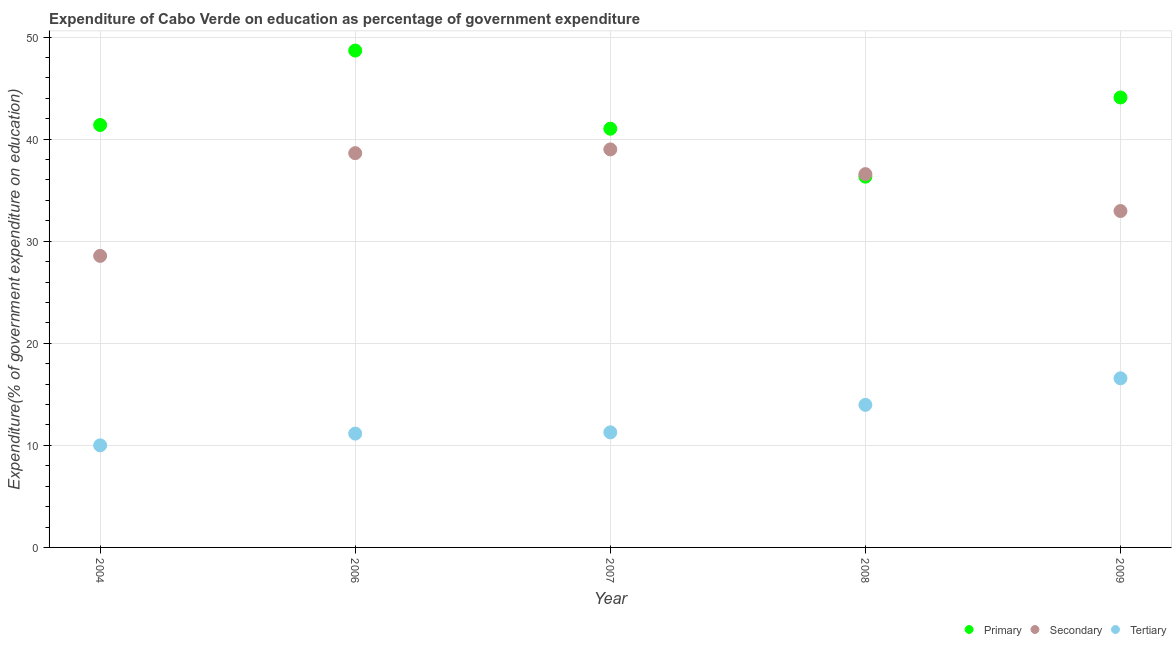How many different coloured dotlines are there?
Offer a very short reply. 3. What is the expenditure on primary education in 2007?
Offer a terse response. 41.02. Across all years, what is the maximum expenditure on secondary education?
Ensure brevity in your answer.  38.99. Across all years, what is the minimum expenditure on primary education?
Ensure brevity in your answer.  36.32. In which year was the expenditure on tertiary education maximum?
Offer a very short reply. 2009. What is the total expenditure on tertiary education in the graph?
Ensure brevity in your answer.  62.96. What is the difference between the expenditure on tertiary education in 2006 and that in 2009?
Provide a succinct answer. -5.42. What is the difference between the expenditure on primary education in 2007 and the expenditure on secondary education in 2004?
Make the answer very short. 12.46. What is the average expenditure on secondary education per year?
Provide a short and direct response. 35.14. In the year 2008, what is the difference between the expenditure on primary education and expenditure on secondary education?
Offer a very short reply. -0.25. What is the ratio of the expenditure on secondary education in 2006 to that in 2008?
Provide a succinct answer. 1.06. Is the expenditure on secondary education in 2008 less than that in 2009?
Offer a very short reply. No. Is the difference between the expenditure on secondary education in 2006 and 2009 greater than the difference between the expenditure on tertiary education in 2006 and 2009?
Provide a succinct answer. Yes. What is the difference between the highest and the second highest expenditure on primary education?
Give a very brief answer. 4.6. What is the difference between the highest and the lowest expenditure on secondary education?
Provide a succinct answer. 10.43. In how many years, is the expenditure on secondary education greater than the average expenditure on secondary education taken over all years?
Your answer should be compact. 3. Does the expenditure on primary education monotonically increase over the years?
Offer a very short reply. No. Is the expenditure on primary education strictly greater than the expenditure on tertiary education over the years?
Make the answer very short. Yes. Is the expenditure on tertiary education strictly less than the expenditure on secondary education over the years?
Offer a terse response. Yes. How many dotlines are there?
Keep it short and to the point. 3. What is the difference between two consecutive major ticks on the Y-axis?
Your response must be concise. 10. Are the values on the major ticks of Y-axis written in scientific E-notation?
Ensure brevity in your answer.  No. Does the graph contain grids?
Your answer should be compact. Yes. Where does the legend appear in the graph?
Make the answer very short. Bottom right. What is the title of the graph?
Give a very brief answer. Expenditure of Cabo Verde on education as percentage of government expenditure. What is the label or title of the Y-axis?
Provide a succinct answer. Expenditure(% of government expenditure on education). What is the Expenditure(% of government expenditure on education) of Primary in 2004?
Offer a very short reply. 41.38. What is the Expenditure(% of government expenditure on education) in Secondary in 2004?
Your response must be concise. 28.56. What is the Expenditure(% of government expenditure on education) in Tertiary in 2004?
Provide a succinct answer. 10. What is the Expenditure(% of government expenditure on education) in Primary in 2006?
Your answer should be compact. 48.68. What is the Expenditure(% of government expenditure on education) of Secondary in 2006?
Ensure brevity in your answer.  38.63. What is the Expenditure(% of government expenditure on education) in Tertiary in 2006?
Provide a short and direct response. 11.15. What is the Expenditure(% of government expenditure on education) of Primary in 2007?
Offer a terse response. 41.02. What is the Expenditure(% of government expenditure on education) of Secondary in 2007?
Ensure brevity in your answer.  38.99. What is the Expenditure(% of government expenditure on education) of Tertiary in 2007?
Your answer should be compact. 11.27. What is the Expenditure(% of government expenditure on education) in Primary in 2008?
Your response must be concise. 36.32. What is the Expenditure(% of government expenditure on education) of Secondary in 2008?
Your answer should be compact. 36.57. What is the Expenditure(% of government expenditure on education) in Tertiary in 2008?
Provide a succinct answer. 13.97. What is the Expenditure(% of government expenditure on education) in Primary in 2009?
Offer a very short reply. 44.08. What is the Expenditure(% of government expenditure on education) of Secondary in 2009?
Provide a short and direct response. 32.96. What is the Expenditure(% of government expenditure on education) of Tertiary in 2009?
Offer a very short reply. 16.57. Across all years, what is the maximum Expenditure(% of government expenditure on education) in Primary?
Offer a very short reply. 48.68. Across all years, what is the maximum Expenditure(% of government expenditure on education) in Secondary?
Offer a terse response. 38.99. Across all years, what is the maximum Expenditure(% of government expenditure on education) of Tertiary?
Keep it short and to the point. 16.57. Across all years, what is the minimum Expenditure(% of government expenditure on education) in Primary?
Offer a very short reply. 36.32. Across all years, what is the minimum Expenditure(% of government expenditure on education) in Secondary?
Provide a succinct answer. 28.56. Across all years, what is the minimum Expenditure(% of government expenditure on education) in Tertiary?
Offer a terse response. 10. What is the total Expenditure(% of government expenditure on education) of Primary in the graph?
Your answer should be very brief. 211.49. What is the total Expenditure(% of government expenditure on education) of Secondary in the graph?
Offer a terse response. 175.71. What is the total Expenditure(% of government expenditure on education) in Tertiary in the graph?
Make the answer very short. 62.96. What is the difference between the Expenditure(% of government expenditure on education) of Primary in 2004 and that in 2006?
Make the answer very short. -7.29. What is the difference between the Expenditure(% of government expenditure on education) in Secondary in 2004 and that in 2006?
Offer a very short reply. -10.06. What is the difference between the Expenditure(% of government expenditure on education) of Tertiary in 2004 and that in 2006?
Your response must be concise. -1.15. What is the difference between the Expenditure(% of government expenditure on education) in Primary in 2004 and that in 2007?
Your answer should be compact. 0.36. What is the difference between the Expenditure(% of government expenditure on education) of Secondary in 2004 and that in 2007?
Keep it short and to the point. -10.43. What is the difference between the Expenditure(% of government expenditure on education) of Tertiary in 2004 and that in 2007?
Give a very brief answer. -1.28. What is the difference between the Expenditure(% of government expenditure on education) of Primary in 2004 and that in 2008?
Keep it short and to the point. 5.06. What is the difference between the Expenditure(% of government expenditure on education) of Secondary in 2004 and that in 2008?
Your response must be concise. -8.01. What is the difference between the Expenditure(% of government expenditure on education) in Tertiary in 2004 and that in 2008?
Keep it short and to the point. -3.97. What is the difference between the Expenditure(% of government expenditure on education) of Primary in 2004 and that in 2009?
Offer a terse response. -2.7. What is the difference between the Expenditure(% of government expenditure on education) in Secondary in 2004 and that in 2009?
Provide a succinct answer. -4.4. What is the difference between the Expenditure(% of government expenditure on education) in Tertiary in 2004 and that in 2009?
Your response must be concise. -6.57. What is the difference between the Expenditure(% of government expenditure on education) of Primary in 2006 and that in 2007?
Your answer should be very brief. 7.66. What is the difference between the Expenditure(% of government expenditure on education) in Secondary in 2006 and that in 2007?
Your answer should be very brief. -0.37. What is the difference between the Expenditure(% of government expenditure on education) of Tertiary in 2006 and that in 2007?
Offer a terse response. -0.12. What is the difference between the Expenditure(% of government expenditure on education) in Primary in 2006 and that in 2008?
Provide a short and direct response. 12.35. What is the difference between the Expenditure(% of government expenditure on education) of Secondary in 2006 and that in 2008?
Offer a terse response. 2.05. What is the difference between the Expenditure(% of government expenditure on education) in Tertiary in 2006 and that in 2008?
Offer a terse response. -2.81. What is the difference between the Expenditure(% of government expenditure on education) in Primary in 2006 and that in 2009?
Your answer should be compact. 4.6. What is the difference between the Expenditure(% of government expenditure on education) of Secondary in 2006 and that in 2009?
Provide a short and direct response. 5.67. What is the difference between the Expenditure(% of government expenditure on education) in Tertiary in 2006 and that in 2009?
Your answer should be very brief. -5.42. What is the difference between the Expenditure(% of government expenditure on education) in Primary in 2007 and that in 2008?
Ensure brevity in your answer.  4.7. What is the difference between the Expenditure(% of government expenditure on education) of Secondary in 2007 and that in 2008?
Offer a terse response. 2.42. What is the difference between the Expenditure(% of government expenditure on education) in Tertiary in 2007 and that in 2008?
Your answer should be very brief. -2.69. What is the difference between the Expenditure(% of government expenditure on education) in Primary in 2007 and that in 2009?
Provide a succinct answer. -3.06. What is the difference between the Expenditure(% of government expenditure on education) in Secondary in 2007 and that in 2009?
Provide a succinct answer. 6.04. What is the difference between the Expenditure(% of government expenditure on education) of Tertiary in 2007 and that in 2009?
Provide a succinct answer. -5.3. What is the difference between the Expenditure(% of government expenditure on education) in Primary in 2008 and that in 2009?
Your answer should be very brief. -7.76. What is the difference between the Expenditure(% of government expenditure on education) of Secondary in 2008 and that in 2009?
Your answer should be compact. 3.62. What is the difference between the Expenditure(% of government expenditure on education) of Tertiary in 2008 and that in 2009?
Ensure brevity in your answer.  -2.6. What is the difference between the Expenditure(% of government expenditure on education) in Primary in 2004 and the Expenditure(% of government expenditure on education) in Secondary in 2006?
Provide a succinct answer. 2.76. What is the difference between the Expenditure(% of government expenditure on education) in Primary in 2004 and the Expenditure(% of government expenditure on education) in Tertiary in 2006?
Ensure brevity in your answer.  30.23. What is the difference between the Expenditure(% of government expenditure on education) in Secondary in 2004 and the Expenditure(% of government expenditure on education) in Tertiary in 2006?
Your response must be concise. 17.41. What is the difference between the Expenditure(% of government expenditure on education) of Primary in 2004 and the Expenditure(% of government expenditure on education) of Secondary in 2007?
Your response must be concise. 2.39. What is the difference between the Expenditure(% of government expenditure on education) of Primary in 2004 and the Expenditure(% of government expenditure on education) of Tertiary in 2007?
Your answer should be very brief. 30.11. What is the difference between the Expenditure(% of government expenditure on education) of Secondary in 2004 and the Expenditure(% of government expenditure on education) of Tertiary in 2007?
Ensure brevity in your answer.  17.29. What is the difference between the Expenditure(% of government expenditure on education) of Primary in 2004 and the Expenditure(% of government expenditure on education) of Secondary in 2008?
Make the answer very short. 4.81. What is the difference between the Expenditure(% of government expenditure on education) of Primary in 2004 and the Expenditure(% of government expenditure on education) of Tertiary in 2008?
Your answer should be very brief. 27.42. What is the difference between the Expenditure(% of government expenditure on education) of Secondary in 2004 and the Expenditure(% of government expenditure on education) of Tertiary in 2008?
Your response must be concise. 14.6. What is the difference between the Expenditure(% of government expenditure on education) of Primary in 2004 and the Expenditure(% of government expenditure on education) of Secondary in 2009?
Offer a very short reply. 8.43. What is the difference between the Expenditure(% of government expenditure on education) in Primary in 2004 and the Expenditure(% of government expenditure on education) in Tertiary in 2009?
Your answer should be compact. 24.81. What is the difference between the Expenditure(% of government expenditure on education) of Secondary in 2004 and the Expenditure(% of government expenditure on education) of Tertiary in 2009?
Make the answer very short. 11.99. What is the difference between the Expenditure(% of government expenditure on education) of Primary in 2006 and the Expenditure(% of government expenditure on education) of Secondary in 2007?
Provide a short and direct response. 9.68. What is the difference between the Expenditure(% of government expenditure on education) of Primary in 2006 and the Expenditure(% of government expenditure on education) of Tertiary in 2007?
Your response must be concise. 37.4. What is the difference between the Expenditure(% of government expenditure on education) of Secondary in 2006 and the Expenditure(% of government expenditure on education) of Tertiary in 2007?
Offer a terse response. 27.35. What is the difference between the Expenditure(% of government expenditure on education) in Primary in 2006 and the Expenditure(% of government expenditure on education) in Secondary in 2008?
Your answer should be very brief. 12.1. What is the difference between the Expenditure(% of government expenditure on education) of Primary in 2006 and the Expenditure(% of government expenditure on education) of Tertiary in 2008?
Offer a terse response. 34.71. What is the difference between the Expenditure(% of government expenditure on education) in Secondary in 2006 and the Expenditure(% of government expenditure on education) in Tertiary in 2008?
Make the answer very short. 24.66. What is the difference between the Expenditure(% of government expenditure on education) in Primary in 2006 and the Expenditure(% of government expenditure on education) in Secondary in 2009?
Make the answer very short. 15.72. What is the difference between the Expenditure(% of government expenditure on education) of Primary in 2006 and the Expenditure(% of government expenditure on education) of Tertiary in 2009?
Your answer should be compact. 32.11. What is the difference between the Expenditure(% of government expenditure on education) in Secondary in 2006 and the Expenditure(% of government expenditure on education) in Tertiary in 2009?
Your answer should be compact. 22.06. What is the difference between the Expenditure(% of government expenditure on education) of Primary in 2007 and the Expenditure(% of government expenditure on education) of Secondary in 2008?
Ensure brevity in your answer.  4.45. What is the difference between the Expenditure(% of government expenditure on education) of Primary in 2007 and the Expenditure(% of government expenditure on education) of Tertiary in 2008?
Offer a very short reply. 27.05. What is the difference between the Expenditure(% of government expenditure on education) in Secondary in 2007 and the Expenditure(% of government expenditure on education) in Tertiary in 2008?
Offer a very short reply. 25.03. What is the difference between the Expenditure(% of government expenditure on education) in Primary in 2007 and the Expenditure(% of government expenditure on education) in Secondary in 2009?
Your answer should be compact. 8.06. What is the difference between the Expenditure(% of government expenditure on education) in Primary in 2007 and the Expenditure(% of government expenditure on education) in Tertiary in 2009?
Provide a short and direct response. 24.45. What is the difference between the Expenditure(% of government expenditure on education) of Secondary in 2007 and the Expenditure(% of government expenditure on education) of Tertiary in 2009?
Offer a very short reply. 22.42. What is the difference between the Expenditure(% of government expenditure on education) in Primary in 2008 and the Expenditure(% of government expenditure on education) in Secondary in 2009?
Ensure brevity in your answer.  3.37. What is the difference between the Expenditure(% of government expenditure on education) in Primary in 2008 and the Expenditure(% of government expenditure on education) in Tertiary in 2009?
Your answer should be very brief. 19.75. What is the difference between the Expenditure(% of government expenditure on education) of Secondary in 2008 and the Expenditure(% of government expenditure on education) of Tertiary in 2009?
Your response must be concise. 20. What is the average Expenditure(% of government expenditure on education) of Primary per year?
Offer a very short reply. 42.3. What is the average Expenditure(% of government expenditure on education) in Secondary per year?
Offer a very short reply. 35.14. What is the average Expenditure(% of government expenditure on education) in Tertiary per year?
Offer a terse response. 12.59. In the year 2004, what is the difference between the Expenditure(% of government expenditure on education) of Primary and Expenditure(% of government expenditure on education) of Secondary?
Ensure brevity in your answer.  12.82. In the year 2004, what is the difference between the Expenditure(% of government expenditure on education) in Primary and Expenditure(% of government expenditure on education) in Tertiary?
Provide a short and direct response. 31.39. In the year 2004, what is the difference between the Expenditure(% of government expenditure on education) of Secondary and Expenditure(% of government expenditure on education) of Tertiary?
Make the answer very short. 18.56. In the year 2006, what is the difference between the Expenditure(% of government expenditure on education) in Primary and Expenditure(% of government expenditure on education) in Secondary?
Provide a succinct answer. 10.05. In the year 2006, what is the difference between the Expenditure(% of government expenditure on education) of Primary and Expenditure(% of government expenditure on education) of Tertiary?
Ensure brevity in your answer.  37.53. In the year 2006, what is the difference between the Expenditure(% of government expenditure on education) in Secondary and Expenditure(% of government expenditure on education) in Tertiary?
Make the answer very short. 27.47. In the year 2007, what is the difference between the Expenditure(% of government expenditure on education) of Primary and Expenditure(% of government expenditure on education) of Secondary?
Make the answer very short. 2.03. In the year 2007, what is the difference between the Expenditure(% of government expenditure on education) in Primary and Expenditure(% of government expenditure on education) in Tertiary?
Your answer should be compact. 29.75. In the year 2007, what is the difference between the Expenditure(% of government expenditure on education) of Secondary and Expenditure(% of government expenditure on education) of Tertiary?
Offer a very short reply. 27.72. In the year 2008, what is the difference between the Expenditure(% of government expenditure on education) of Primary and Expenditure(% of government expenditure on education) of Secondary?
Offer a very short reply. -0.25. In the year 2008, what is the difference between the Expenditure(% of government expenditure on education) in Primary and Expenditure(% of government expenditure on education) in Tertiary?
Your answer should be compact. 22.36. In the year 2008, what is the difference between the Expenditure(% of government expenditure on education) of Secondary and Expenditure(% of government expenditure on education) of Tertiary?
Ensure brevity in your answer.  22.61. In the year 2009, what is the difference between the Expenditure(% of government expenditure on education) of Primary and Expenditure(% of government expenditure on education) of Secondary?
Keep it short and to the point. 11.12. In the year 2009, what is the difference between the Expenditure(% of government expenditure on education) in Primary and Expenditure(% of government expenditure on education) in Tertiary?
Your answer should be compact. 27.51. In the year 2009, what is the difference between the Expenditure(% of government expenditure on education) in Secondary and Expenditure(% of government expenditure on education) in Tertiary?
Keep it short and to the point. 16.39. What is the ratio of the Expenditure(% of government expenditure on education) in Primary in 2004 to that in 2006?
Provide a succinct answer. 0.85. What is the ratio of the Expenditure(% of government expenditure on education) in Secondary in 2004 to that in 2006?
Offer a terse response. 0.74. What is the ratio of the Expenditure(% of government expenditure on education) in Tertiary in 2004 to that in 2006?
Make the answer very short. 0.9. What is the ratio of the Expenditure(% of government expenditure on education) in Primary in 2004 to that in 2007?
Your response must be concise. 1.01. What is the ratio of the Expenditure(% of government expenditure on education) of Secondary in 2004 to that in 2007?
Offer a terse response. 0.73. What is the ratio of the Expenditure(% of government expenditure on education) of Tertiary in 2004 to that in 2007?
Your answer should be compact. 0.89. What is the ratio of the Expenditure(% of government expenditure on education) of Primary in 2004 to that in 2008?
Keep it short and to the point. 1.14. What is the ratio of the Expenditure(% of government expenditure on education) of Secondary in 2004 to that in 2008?
Your answer should be very brief. 0.78. What is the ratio of the Expenditure(% of government expenditure on education) in Tertiary in 2004 to that in 2008?
Your answer should be very brief. 0.72. What is the ratio of the Expenditure(% of government expenditure on education) in Primary in 2004 to that in 2009?
Your answer should be very brief. 0.94. What is the ratio of the Expenditure(% of government expenditure on education) in Secondary in 2004 to that in 2009?
Ensure brevity in your answer.  0.87. What is the ratio of the Expenditure(% of government expenditure on education) in Tertiary in 2004 to that in 2009?
Your response must be concise. 0.6. What is the ratio of the Expenditure(% of government expenditure on education) of Primary in 2006 to that in 2007?
Your answer should be very brief. 1.19. What is the ratio of the Expenditure(% of government expenditure on education) of Secondary in 2006 to that in 2007?
Provide a succinct answer. 0.99. What is the ratio of the Expenditure(% of government expenditure on education) in Tertiary in 2006 to that in 2007?
Offer a very short reply. 0.99. What is the ratio of the Expenditure(% of government expenditure on education) of Primary in 2006 to that in 2008?
Provide a short and direct response. 1.34. What is the ratio of the Expenditure(% of government expenditure on education) in Secondary in 2006 to that in 2008?
Your answer should be compact. 1.06. What is the ratio of the Expenditure(% of government expenditure on education) of Tertiary in 2006 to that in 2008?
Give a very brief answer. 0.8. What is the ratio of the Expenditure(% of government expenditure on education) in Primary in 2006 to that in 2009?
Ensure brevity in your answer.  1.1. What is the ratio of the Expenditure(% of government expenditure on education) of Secondary in 2006 to that in 2009?
Your answer should be compact. 1.17. What is the ratio of the Expenditure(% of government expenditure on education) of Tertiary in 2006 to that in 2009?
Ensure brevity in your answer.  0.67. What is the ratio of the Expenditure(% of government expenditure on education) of Primary in 2007 to that in 2008?
Keep it short and to the point. 1.13. What is the ratio of the Expenditure(% of government expenditure on education) in Secondary in 2007 to that in 2008?
Provide a short and direct response. 1.07. What is the ratio of the Expenditure(% of government expenditure on education) in Tertiary in 2007 to that in 2008?
Provide a succinct answer. 0.81. What is the ratio of the Expenditure(% of government expenditure on education) in Primary in 2007 to that in 2009?
Offer a very short reply. 0.93. What is the ratio of the Expenditure(% of government expenditure on education) of Secondary in 2007 to that in 2009?
Make the answer very short. 1.18. What is the ratio of the Expenditure(% of government expenditure on education) in Tertiary in 2007 to that in 2009?
Offer a terse response. 0.68. What is the ratio of the Expenditure(% of government expenditure on education) in Primary in 2008 to that in 2009?
Your answer should be compact. 0.82. What is the ratio of the Expenditure(% of government expenditure on education) of Secondary in 2008 to that in 2009?
Your answer should be very brief. 1.11. What is the ratio of the Expenditure(% of government expenditure on education) of Tertiary in 2008 to that in 2009?
Offer a terse response. 0.84. What is the difference between the highest and the second highest Expenditure(% of government expenditure on education) in Primary?
Your response must be concise. 4.6. What is the difference between the highest and the second highest Expenditure(% of government expenditure on education) in Secondary?
Your answer should be compact. 0.37. What is the difference between the highest and the second highest Expenditure(% of government expenditure on education) of Tertiary?
Offer a terse response. 2.6. What is the difference between the highest and the lowest Expenditure(% of government expenditure on education) of Primary?
Offer a terse response. 12.35. What is the difference between the highest and the lowest Expenditure(% of government expenditure on education) in Secondary?
Your answer should be very brief. 10.43. What is the difference between the highest and the lowest Expenditure(% of government expenditure on education) in Tertiary?
Ensure brevity in your answer.  6.57. 